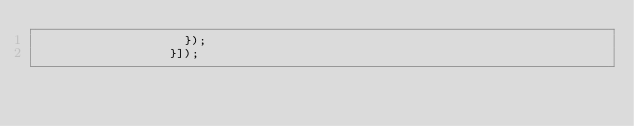Convert code to text. <code><loc_0><loc_0><loc_500><loc_500><_JavaScript_>                    });
                  }]);
</code> 